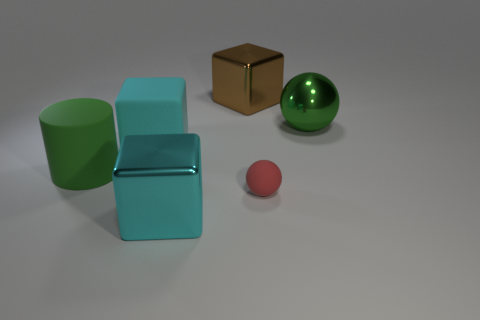How many cyan cubes must be subtracted to get 1 cyan cubes? 1 Add 3 tiny purple matte cubes. How many objects exist? 9 Subtract all spheres. How many objects are left? 4 Add 5 small brown shiny cylinders. How many small brown shiny cylinders exist? 5 Subtract 0 gray blocks. How many objects are left? 6 Subtract all spheres. Subtract all cyan matte cylinders. How many objects are left? 4 Add 3 green metallic objects. How many green metallic objects are left? 4 